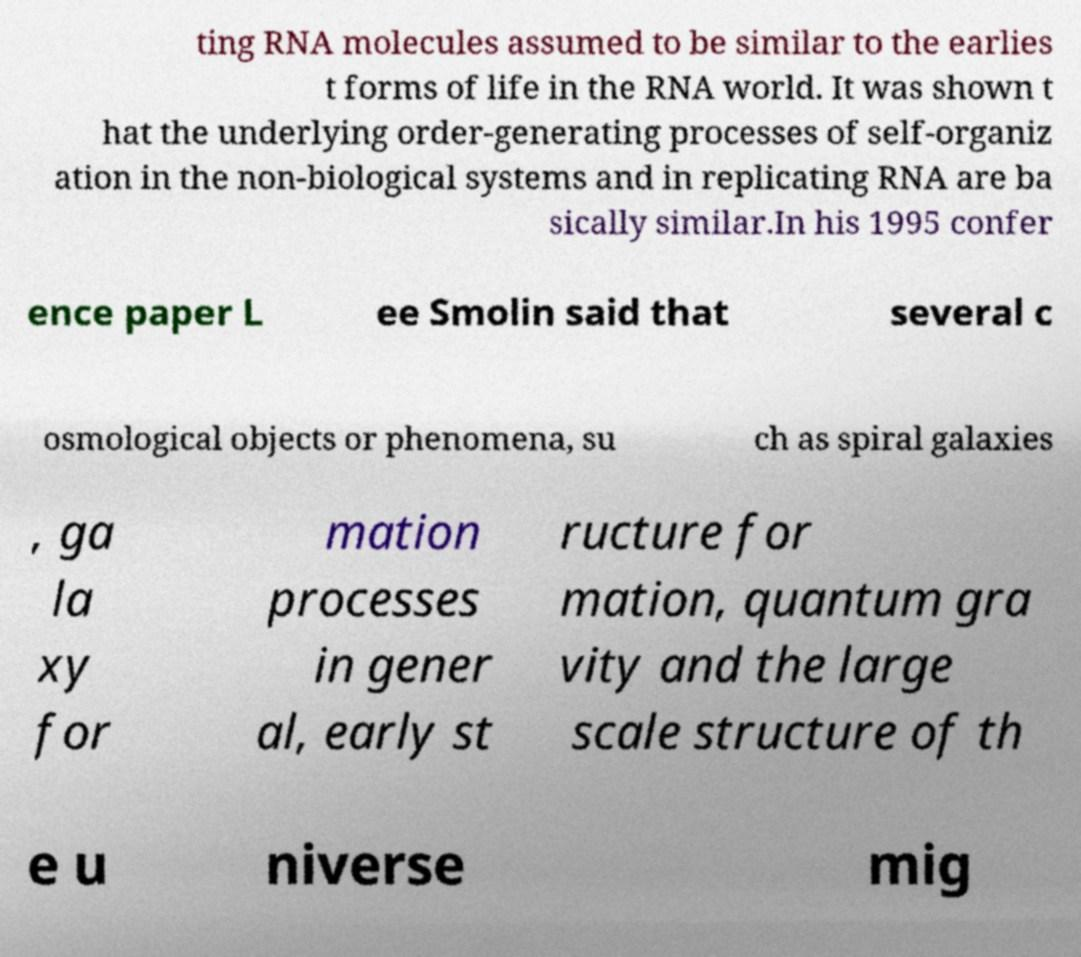Can you accurately transcribe the text from the provided image for me? ting RNA molecules assumed to be similar to the earlies t forms of life in the RNA world. It was shown t hat the underlying order-generating processes of self-organiz ation in the non-biological systems and in replicating RNA are ba sically similar.In his 1995 confer ence paper L ee Smolin said that several c osmological objects or phenomena, su ch as spiral galaxies , ga la xy for mation processes in gener al, early st ructure for mation, quantum gra vity and the large scale structure of th e u niverse mig 